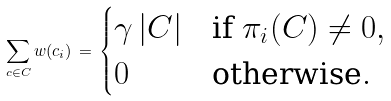Convert formula to latex. <formula><loc_0><loc_0><loc_500><loc_500>\sum _ { c \in C } w ( c _ { i } ) \, = \, \begin{cases} \gamma \, | C | & \text {if $\pi_{i}(C) \neq 0$} , \\ 0 & \text {otherwise} . \end{cases}</formula> 